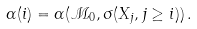<formula> <loc_0><loc_0><loc_500><loc_500>\ { \alpha } ( i ) = \alpha ( \mathcal { M } _ { 0 } , \sigma ( X _ { j } , j \geq i ) ) \, .</formula> 